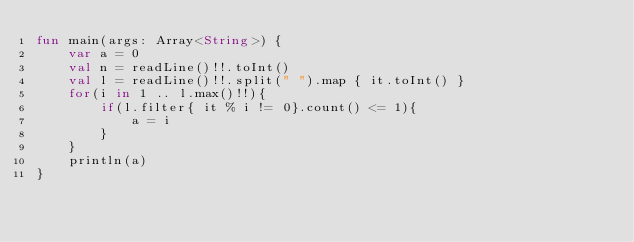Convert code to text. <code><loc_0><loc_0><loc_500><loc_500><_Kotlin_>fun main(args: Array<String>) {
    var a = 0
    val n = readLine()!!.toInt()
    val l = readLine()!!.split(" ").map { it.toInt() }
    for(i in 1 .. l.max()!!){
        if(l.filter{ it % i != 0}.count() <= 1){
            a = i
        }
    }
    println(a)
}
</code> 